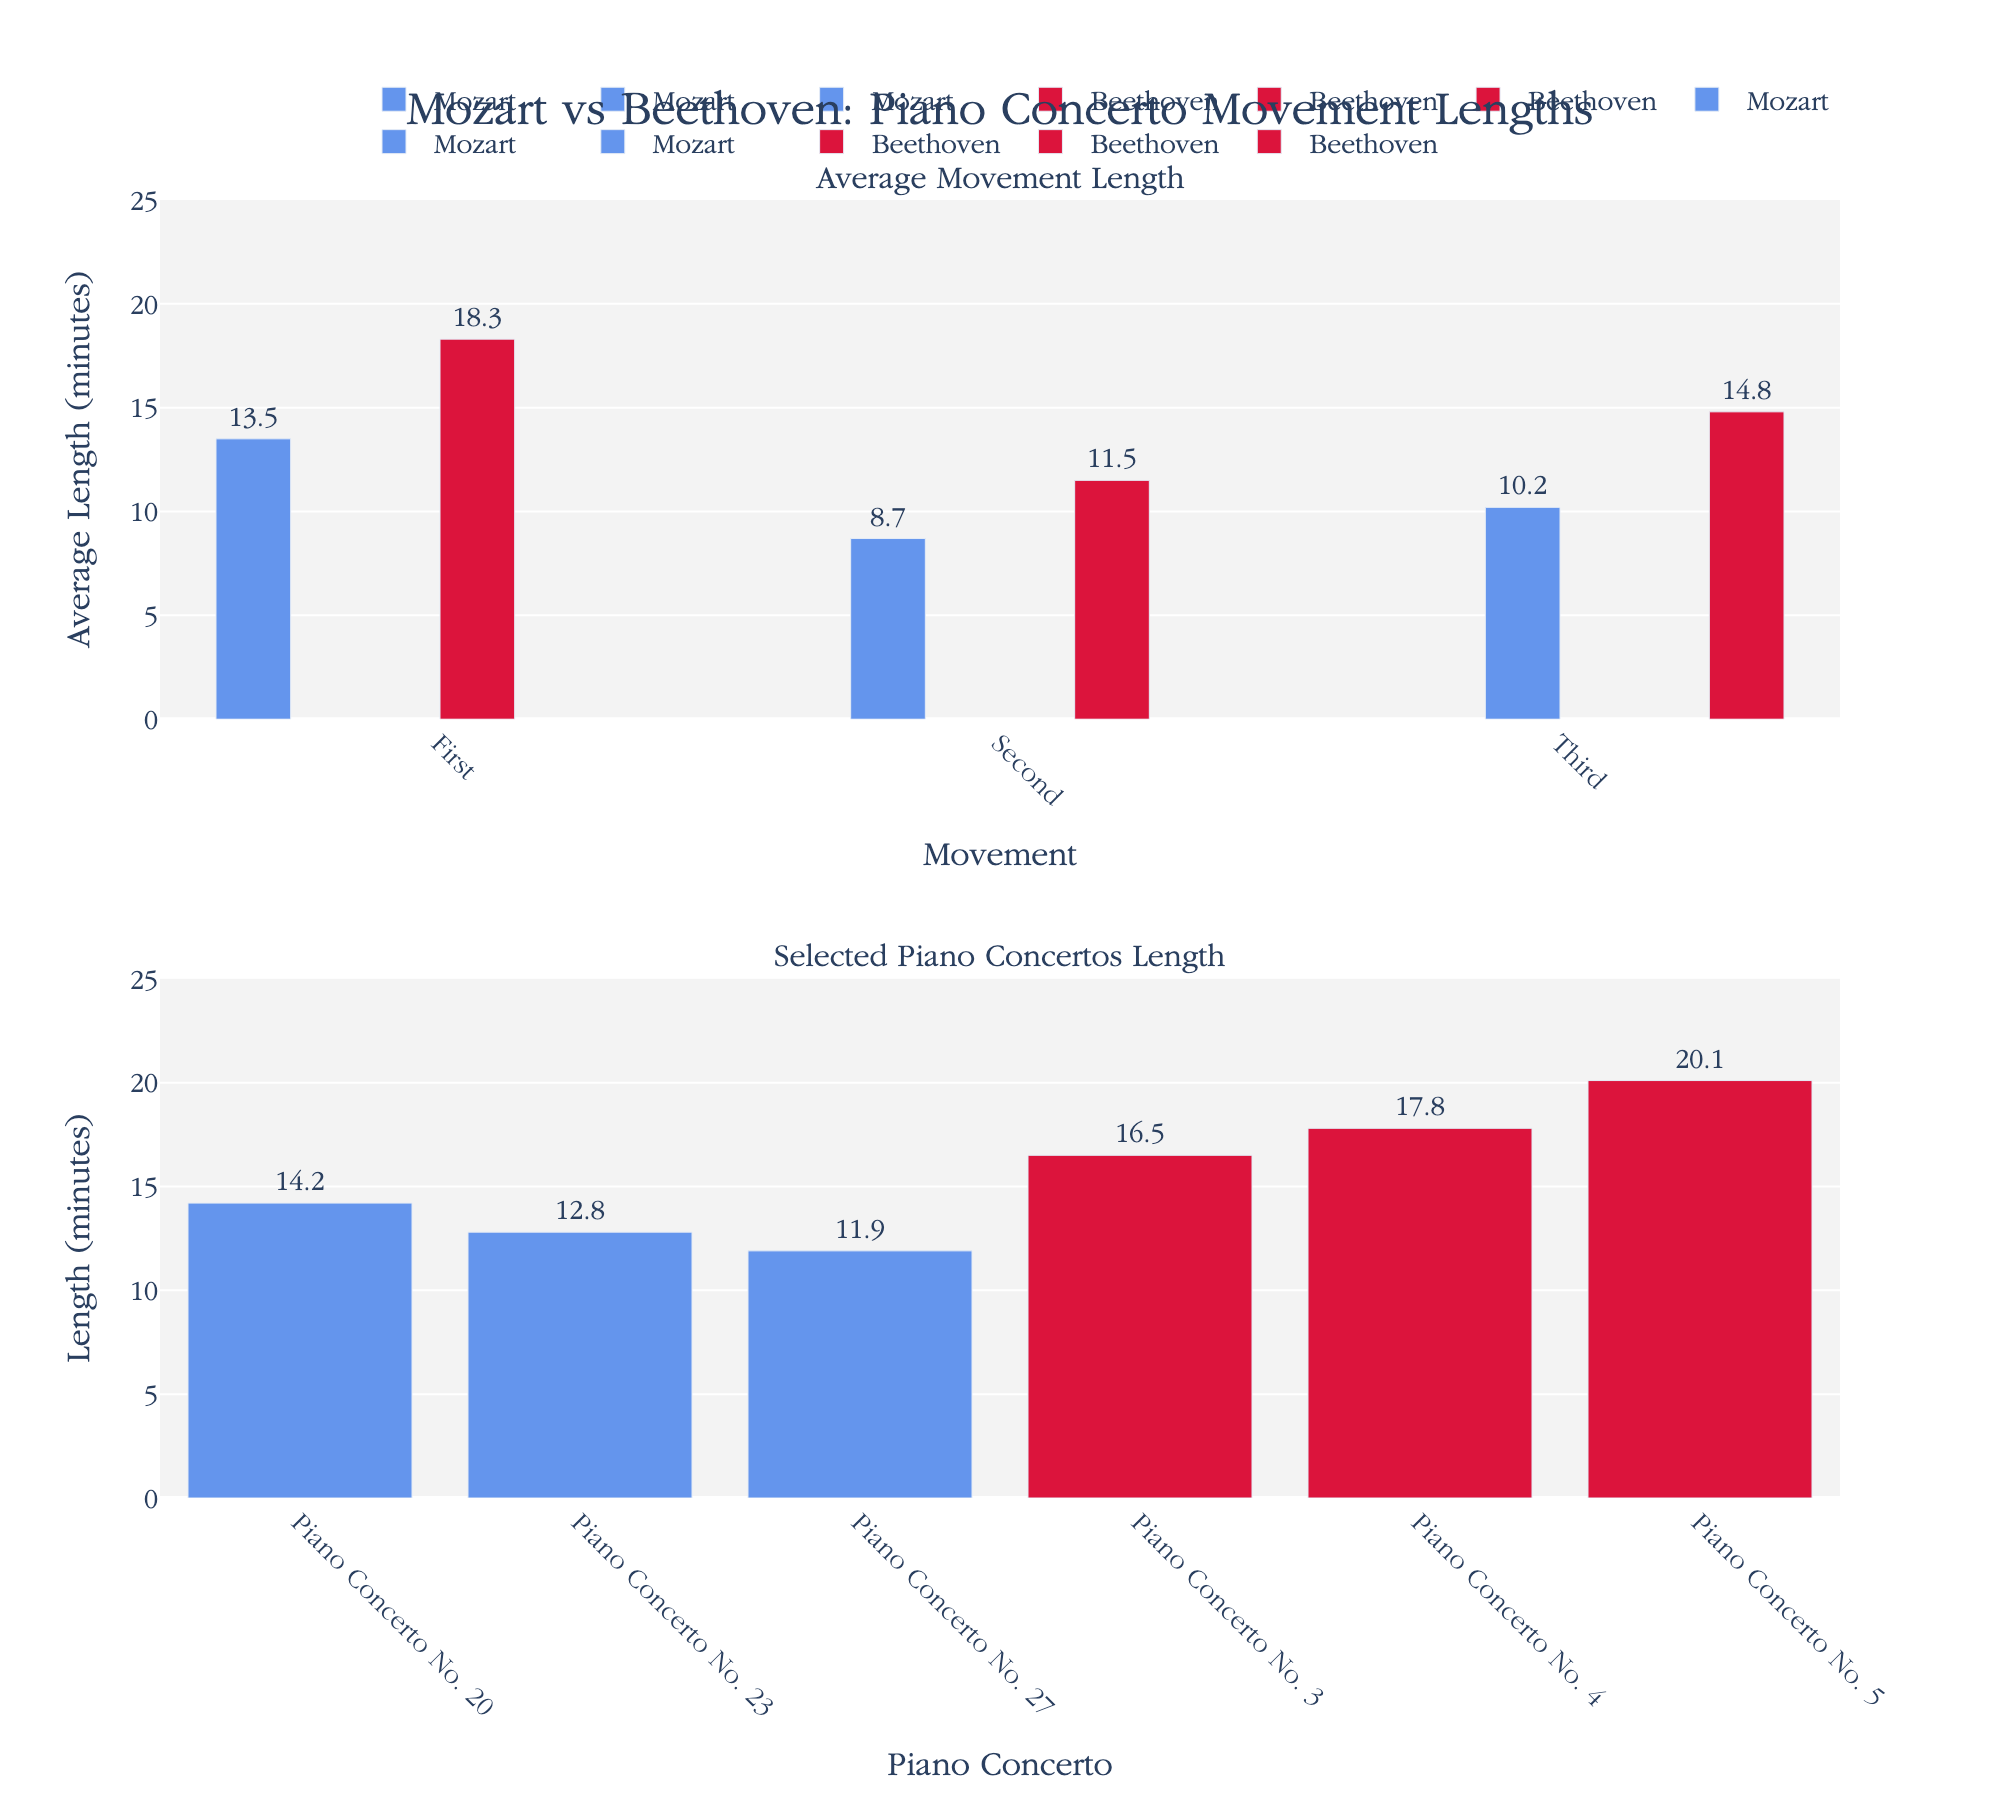Which composer has the longer average First Movement length? The average length of the First Movement for Mozart is 13.5 minutes, while for Beethoven, it is 18.3 minutes. By comparing these two values, Beethoven's average First Movement length is longer.
Answer: Beethoven How long is Mozart's Piano Concerto No. 27 in comparison to Beethoven's Piano Concerto No. 5? Mozart's Piano Concerto No. 27 has a length of 11.9 minutes, while Beethoven's Piano Concerto No. 5 has a length of 20.1 minutes. Comparing the two, Beethoven's Piano Concerto No. 5 is longer.
Answer: Beethoven's Piano Concerto No. 5 What is the average length difference between the Third Movements of Mozart and Beethoven? The Third Movement for Mozart is 10.2 minutes, and for Beethoven, it is 14.8 minutes. The difference is calculated as 14.8 - 10.2 = 4.6 minutes.
Answer: 4.6 minutes Which movement, on average, is the shortest for both composers? Based on the average lengths provided, Mozart's Second Movement is 8.7 minutes, and Beethoven's Second Movement is 11.5 minutes. Therefore, Mozart's Second Movement is the shortest for both composers.
Answer: Second Movement Which of Beethoven's selected Piano Concertos is the longest? Among Beethoven's selected Piano Concertos, No. 3 is 16.5 minutes, No. 4 is 17.8 minutes, and No. 5 is 20.1 minutes. The longest is Piano Concerto No. 5 at 20.1 minutes.
Answer: Piano Concerto No. 5 What is the combined length of Mozart's First and Third Movements? The First Movement length for Mozart is 13.5 minutes, and the Third Movement length is 10.2 minutes. Summing these gives 13.5 + 10.2 = 23.7 minutes.
Answer: 23.7 minutes How much longer is the average length of Beethoven's First Movement compared to Mozart's? Beethoven's First Movement average length is 18.3 minutes, and Mozart's is 13.5 minutes. The difference is 18.3 - 13.5 = 4.8 minutes.
Answer: 4.8 minutes Which selected Mozart Piano Concerto has the shortest length? Among Mozart's selected Piano Concertos, No. 20 is 14.2 minutes, No. 23 is 12.8 minutes, and No. 27 is 11.9 minutes. The shortest is Piano Concerto No. 27 at 11.9 minutes.
Answer: Piano Concerto No. 27 Between the average Second Movements, which composer has the shorter length and by how much? The Second Movement average length for Mozart is 8.7 minutes, while Beethoven's is 11.5 minutes. Mozart's is shorter, and the difference is 11.5 - 8.7 = 2.8 minutes.
Answer: Mozart, by 2.8 minutes 